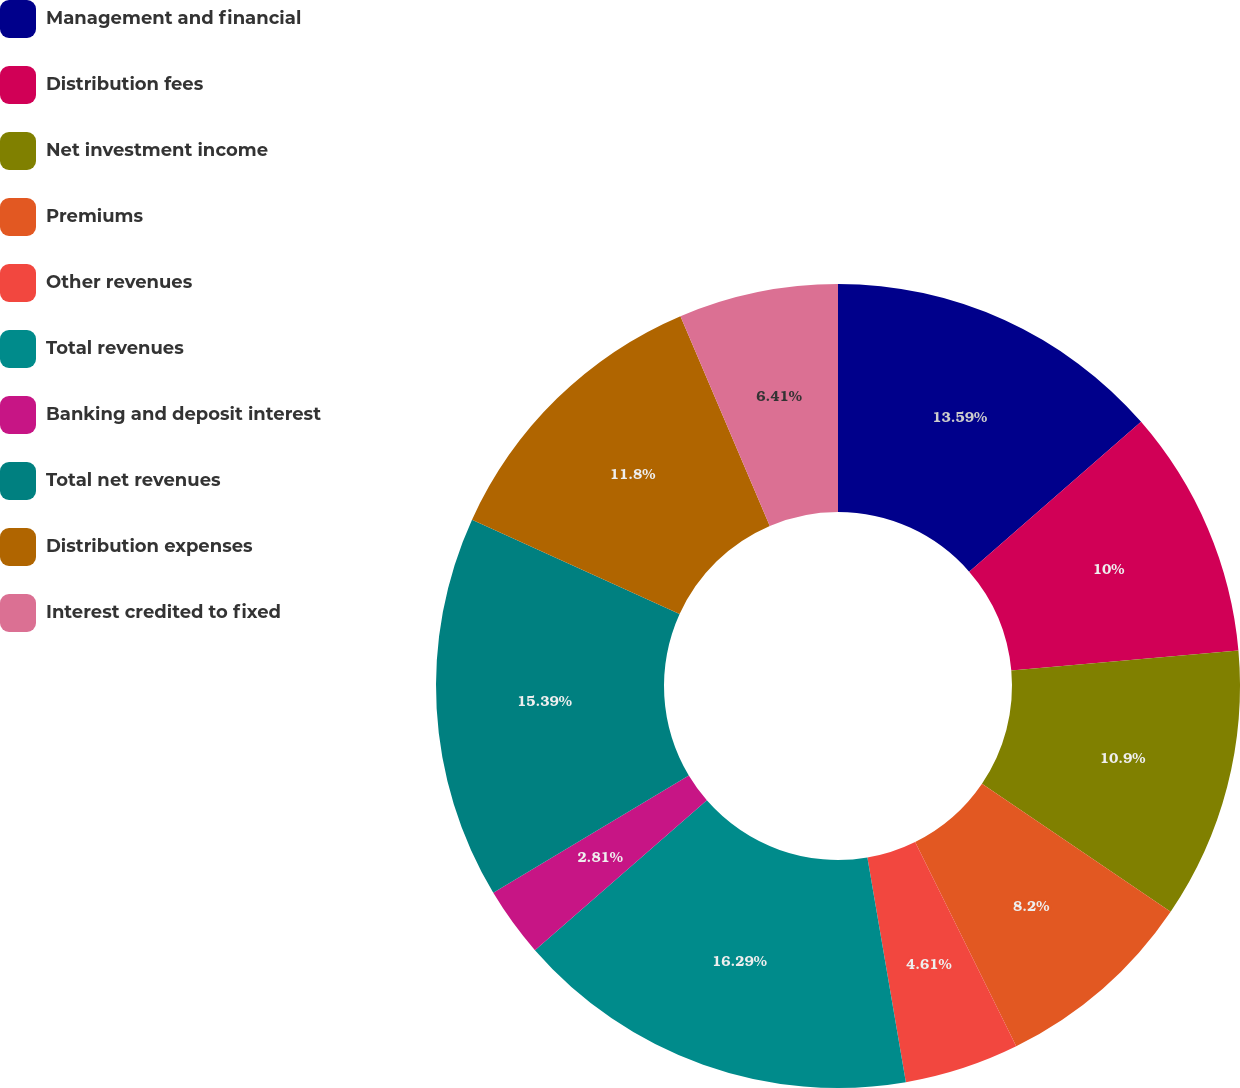Convert chart. <chart><loc_0><loc_0><loc_500><loc_500><pie_chart><fcel>Management and financial<fcel>Distribution fees<fcel>Net investment income<fcel>Premiums<fcel>Other revenues<fcel>Total revenues<fcel>Banking and deposit interest<fcel>Total net revenues<fcel>Distribution expenses<fcel>Interest credited to fixed<nl><fcel>13.59%<fcel>10.0%<fcel>10.9%<fcel>8.2%<fcel>4.61%<fcel>16.29%<fcel>2.81%<fcel>15.39%<fcel>11.8%<fcel>6.41%<nl></chart> 